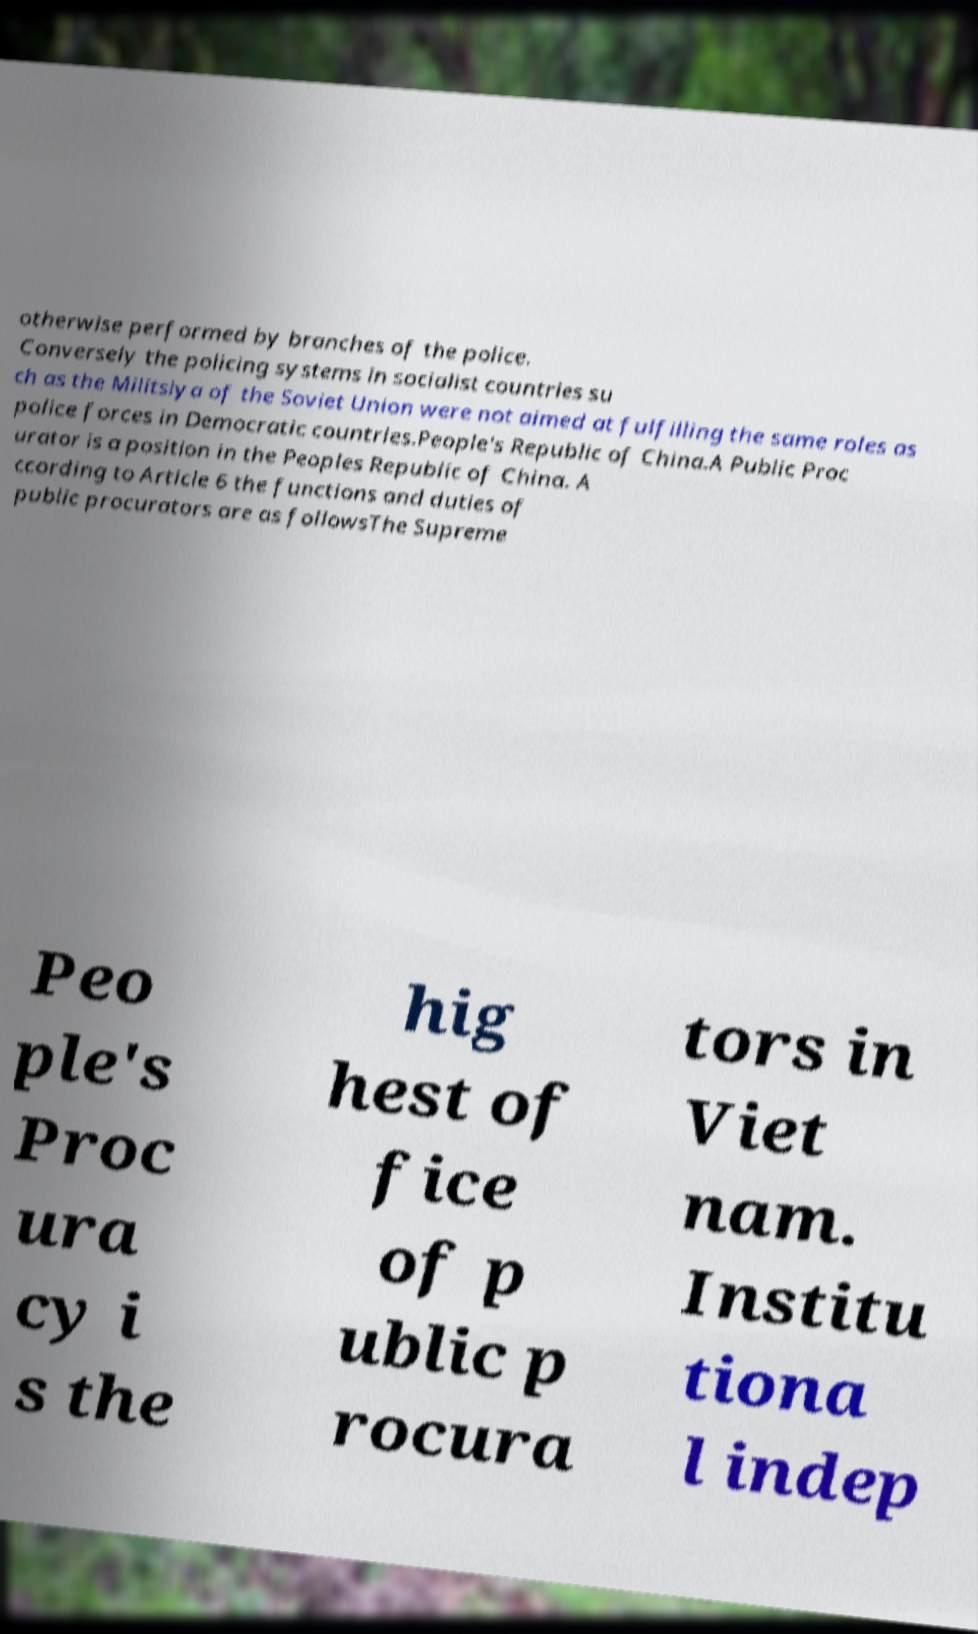Could you extract and type out the text from this image? otherwise performed by branches of the police. Conversely the policing systems in socialist countries su ch as the Militsiya of the Soviet Union were not aimed at fulfilling the same roles as police forces in Democratic countries.People's Republic of China.A Public Proc urator is a position in the Peoples Republic of China. A ccording to Article 6 the functions and duties of public procurators are as followsThe Supreme Peo ple's Proc ura cy i s the hig hest of fice of p ublic p rocura tors in Viet nam. Institu tiona l indep 